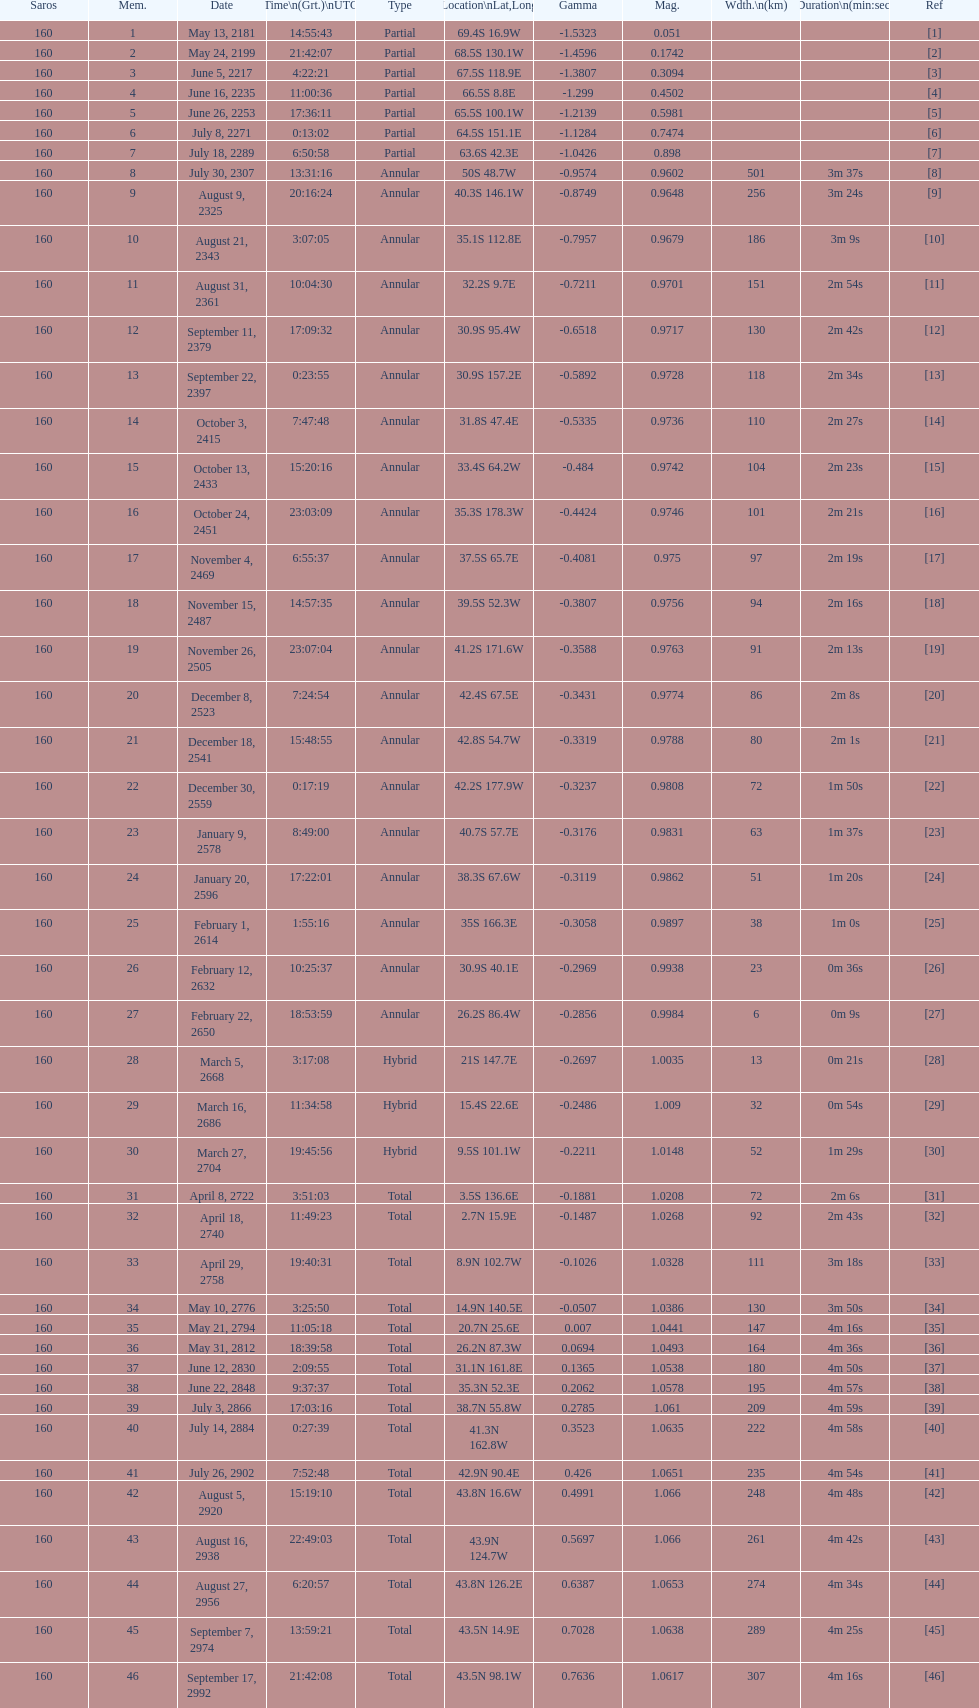What will be the cumulative number of events occurring? 46. Can you give me this table as a dict? {'header': ['Saros', 'Mem.', 'Date', 'Time\\n(Grt.)\\nUTC', 'Type', 'Location\\nLat,Long', 'Gamma', 'Mag.', 'Wdth.\\n(km)', 'Duration\\n(min:sec)', 'Ref'], 'rows': [['160', '1', 'May 13, 2181', '14:55:43', 'Partial', '69.4S 16.9W', '-1.5323', '0.051', '', '', '[1]'], ['160', '2', 'May 24, 2199', '21:42:07', 'Partial', '68.5S 130.1W', '-1.4596', '0.1742', '', '', '[2]'], ['160', '3', 'June 5, 2217', '4:22:21', 'Partial', '67.5S 118.9E', '-1.3807', '0.3094', '', '', '[3]'], ['160', '4', 'June 16, 2235', '11:00:36', 'Partial', '66.5S 8.8E', '-1.299', '0.4502', '', '', '[4]'], ['160', '5', 'June 26, 2253', '17:36:11', 'Partial', '65.5S 100.1W', '-1.2139', '0.5981', '', '', '[5]'], ['160', '6', 'July 8, 2271', '0:13:02', 'Partial', '64.5S 151.1E', '-1.1284', '0.7474', '', '', '[6]'], ['160', '7', 'July 18, 2289', '6:50:58', 'Partial', '63.6S 42.3E', '-1.0426', '0.898', '', '', '[7]'], ['160', '8', 'July 30, 2307', '13:31:16', 'Annular', '50S 48.7W', '-0.9574', '0.9602', '501', '3m 37s', '[8]'], ['160', '9', 'August 9, 2325', '20:16:24', 'Annular', '40.3S 146.1W', '-0.8749', '0.9648', '256', '3m 24s', '[9]'], ['160', '10', 'August 21, 2343', '3:07:05', 'Annular', '35.1S 112.8E', '-0.7957', '0.9679', '186', '3m 9s', '[10]'], ['160', '11', 'August 31, 2361', '10:04:30', 'Annular', '32.2S 9.7E', '-0.7211', '0.9701', '151', '2m 54s', '[11]'], ['160', '12', 'September 11, 2379', '17:09:32', 'Annular', '30.9S 95.4W', '-0.6518', '0.9717', '130', '2m 42s', '[12]'], ['160', '13', 'September 22, 2397', '0:23:55', 'Annular', '30.9S 157.2E', '-0.5892', '0.9728', '118', '2m 34s', '[13]'], ['160', '14', 'October 3, 2415', '7:47:48', 'Annular', '31.8S 47.4E', '-0.5335', '0.9736', '110', '2m 27s', '[14]'], ['160', '15', 'October 13, 2433', '15:20:16', 'Annular', '33.4S 64.2W', '-0.484', '0.9742', '104', '2m 23s', '[15]'], ['160', '16', 'October 24, 2451', '23:03:09', 'Annular', '35.3S 178.3W', '-0.4424', '0.9746', '101', '2m 21s', '[16]'], ['160', '17', 'November 4, 2469', '6:55:37', 'Annular', '37.5S 65.7E', '-0.4081', '0.975', '97', '2m 19s', '[17]'], ['160', '18', 'November 15, 2487', '14:57:35', 'Annular', '39.5S 52.3W', '-0.3807', '0.9756', '94', '2m 16s', '[18]'], ['160', '19', 'November 26, 2505', '23:07:04', 'Annular', '41.2S 171.6W', '-0.3588', '0.9763', '91', '2m 13s', '[19]'], ['160', '20', 'December 8, 2523', '7:24:54', 'Annular', '42.4S 67.5E', '-0.3431', '0.9774', '86', '2m 8s', '[20]'], ['160', '21', 'December 18, 2541', '15:48:55', 'Annular', '42.8S 54.7W', '-0.3319', '0.9788', '80', '2m 1s', '[21]'], ['160', '22', 'December 30, 2559', '0:17:19', 'Annular', '42.2S 177.9W', '-0.3237', '0.9808', '72', '1m 50s', '[22]'], ['160', '23', 'January 9, 2578', '8:49:00', 'Annular', '40.7S 57.7E', '-0.3176', '0.9831', '63', '1m 37s', '[23]'], ['160', '24', 'January 20, 2596', '17:22:01', 'Annular', '38.3S 67.6W', '-0.3119', '0.9862', '51', '1m 20s', '[24]'], ['160', '25', 'February 1, 2614', '1:55:16', 'Annular', '35S 166.3E', '-0.3058', '0.9897', '38', '1m 0s', '[25]'], ['160', '26', 'February 12, 2632', '10:25:37', 'Annular', '30.9S 40.1E', '-0.2969', '0.9938', '23', '0m 36s', '[26]'], ['160', '27', 'February 22, 2650', '18:53:59', 'Annular', '26.2S 86.4W', '-0.2856', '0.9984', '6', '0m 9s', '[27]'], ['160', '28', 'March 5, 2668', '3:17:08', 'Hybrid', '21S 147.7E', '-0.2697', '1.0035', '13', '0m 21s', '[28]'], ['160', '29', 'March 16, 2686', '11:34:58', 'Hybrid', '15.4S 22.6E', '-0.2486', '1.009', '32', '0m 54s', '[29]'], ['160', '30', 'March 27, 2704', '19:45:56', 'Hybrid', '9.5S 101.1W', '-0.2211', '1.0148', '52', '1m 29s', '[30]'], ['160', '31', 'April 8, 2722', '3:51:03', 'Total', '3.5S 136.6E', '-0.1881', '1.0208', '72', '2m 6s', '[31]'], ['160', '32', 'April 18, 2740', '11:49:23', 'Total', '2.7N 15.9E', '-0.1487', '1.0268', '92', '2m 43s', '[32]'], ['160', '33', 'April 29, 2758', '19:40:31', 'Total', '8.9N 102.7W', '-0.1026', '1.0328', '111', '3m 18s', '[33]'], ['160', '34', 'May 10, 2776', '3:25:50', 'Total', '14.9N 140.5E', '-0.0507', '1.0386', '130', '3m 50s', '[34]'], ['160', '35', 'May 21, 2794', '11:05:18', 'Total', '20.7N 25.6E', '0.007', '1.0441', '147', '4m 16s', '[35]'], ['160', '36', 'May 31, 2812', '18:39:58', 'Total', '26.2N 87.3W', '0.0694', '1.0493', '164', '4m 36s', '[36]'], ['160', '37', 'June 12, 2830', '2:09:55', 'Total', '31.1N 161.8E', '0.1365', '1.0538', '180', '4m 50s', '[37]'], ['160', '38', 'June 22, 2848', '9:37:37', 'Total', '35.3N 52.3E', '0.2062', '1.0578', '195', '4m 57s', '[38]'], ['160', '39', 'July 3, 2866', '17:03:16', 'Total', '38.7N 55.8W', '0.2785', '1.061', '209', '4m 59s', '[39]'], ['160', '40', 'July 14, 2884', '0:27:39', 'Total', '41.3N 162.8W', '0.3523', '1.0635', '222', '4m 58s', '[40]'], ['160', '41', 'July 26, 2902', '7:52:48', 'Total', '42.9N 90.4E', '0.426', '1.0651', '235', '4m 54s', '[41]'], ['160', '42', 'August 5, 2920', '15:19:10', 'Total', '43.8N 16.6W', '0.4991', '1.066', '248', '4m 48s', '[42]'], ['160', '43', 'August 16, 2938', '22:49:03', 'Total', '43.9N 124.7W', '0.5697', '1.066', '261', '4m 42s', '[43]'], ['160', '44', 'August 27, 2956', '6:20:57', 'Total', '43.8N 126.2E', '0.6387', '1.0653', '274', '4m 34s', '[44]'], ['160', '45', 'September 7, 2974', '13:59:21', 'Total', '43.5N 14.9E', '0.7028', '1.0638', '289', '4m 25s', '[45]'], ['160', '46', 'September 17, 2992', '21:42:08', 'Total', '43.5N 98.1W', '0.7636', '1.0617', '307', '4m 16s', '[46]']]} 